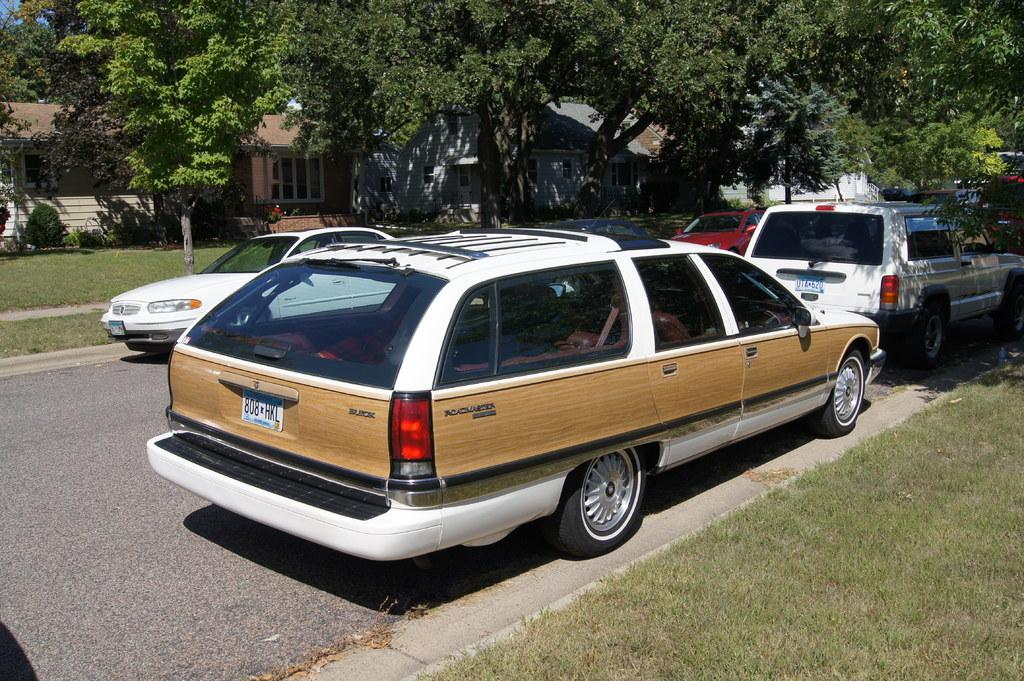<image>
Write a terse but informative summary of the picture. A parked Buick with a license plate number of 808HKL. 